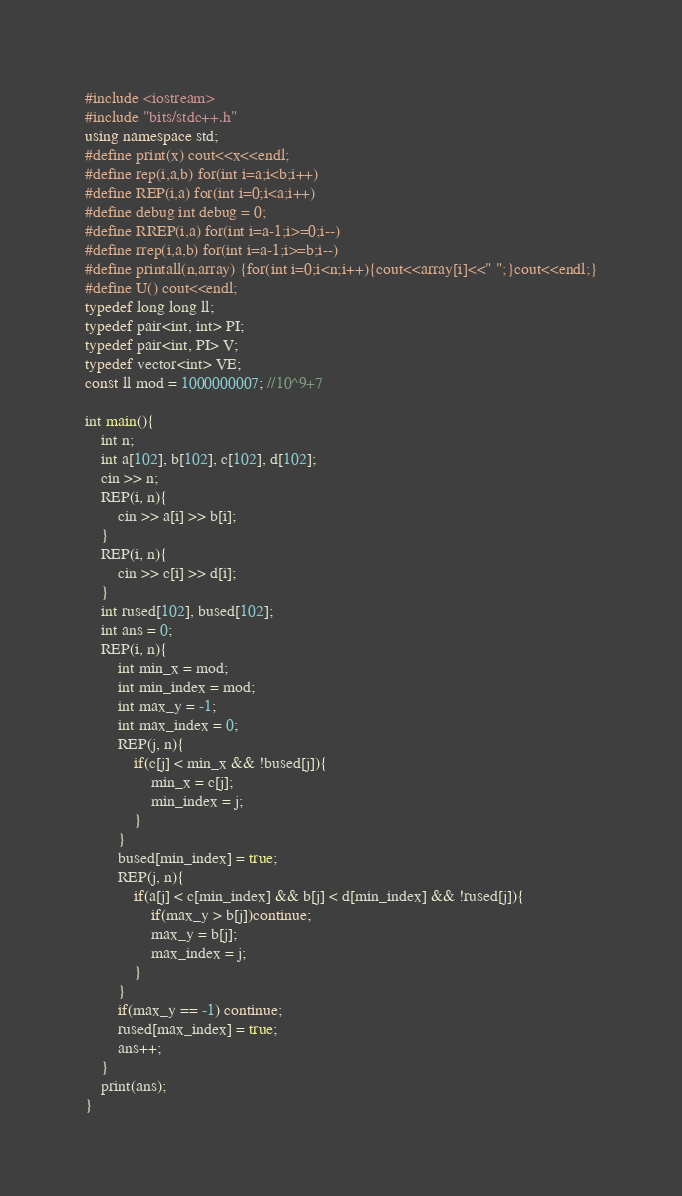<code> <loc_0><loc_0><loc_500><loc_500><_C++_>#include <iostream>
#include "bits/stdc++.h"
using namespace std;
#define print(x) cout<<x<<endl;
#define rep(i,a,b) for(int i=a;i<b;i++)
#define REP(i,a) for(int i=0;i<a;i++)
#define debug int debug = 0;
#define RREP(i,a) for(int i=a-1;i>=0;i--)
#define rrep(i,a,b) for(int i=a-1;i>=b;i--)
#define printall(n,array) {for(int i=0;i<n;i++){cout<<array[i]<<" ";}cout<<endl;}
#define U() cout<<endl;
typedef long long ll;
typedef pair<int, int> PI;
typedef pair<int, PI> V;
typedef vector<int> VE;
const ll mod = 1000000007; //10^9+7

int main(){
    int n;
    int a[102], b[102], c[102], d[102];
    cin >> n;
    REP(i, n){
        cin >> a[i] >> b[i];
    }
    REP(i, n){
        cin >> c[i] >> d[i];
    }
    int rused[102], bused[102];
    int ans = 0;
    REP(i, n){
        int min_x = mod;
        int min_index = mod;
        int max_y = -1;
        int max_index = 0;
        REP(j, n){
            if(c[j] < min_x && !bused[j]){
                min_x = c[j];
                min_index = j;
            }
        }
        bused[min_index] = true;
        REP(j, n){
            if(a[j] < c[min_index] && b[j] < d[min_index] && !rused[j]){
                if(max_y > b[j])continue;
                max_y = b[j];
                max_index = j;
            }
        }
        if(max_y == -1) continue;
        rused[max_index] = true;
        ans++;
    }
    print(ans);
}</code> 